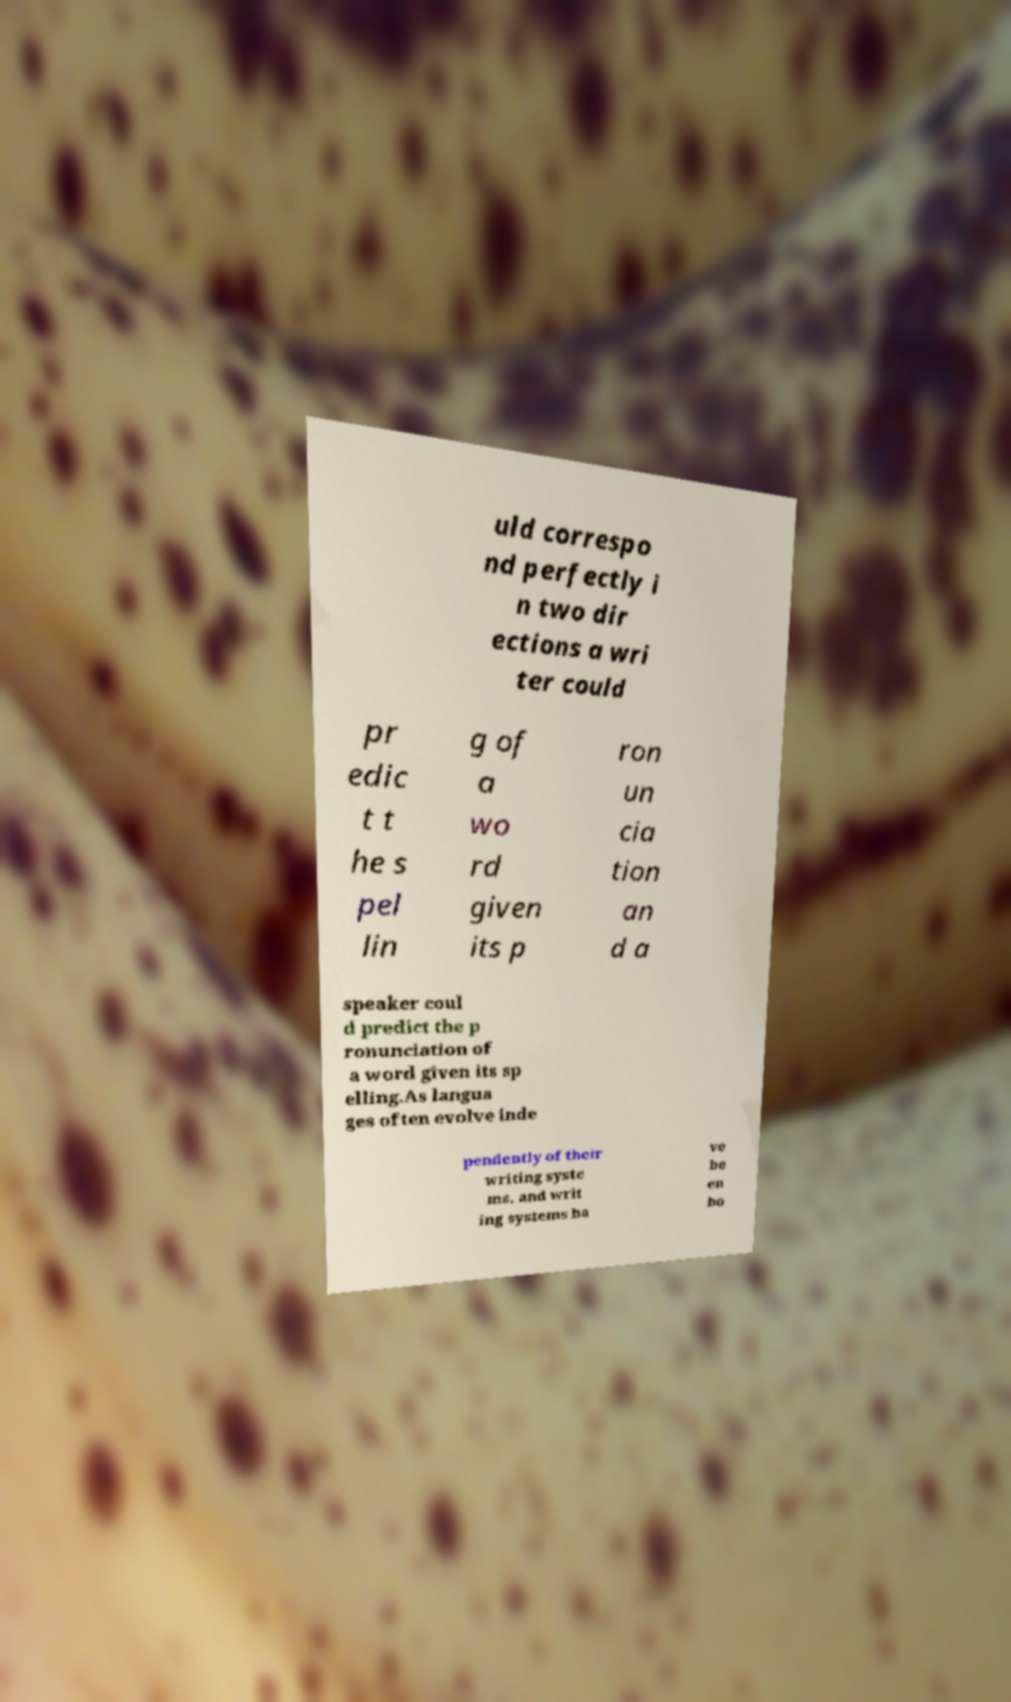There's text embedded in this image that I need extracted. Can you transcribe it verbatim? uld correspo nd perfectly i n two dir ections a wri ter could pr edic t t he s pel lin g of a wo rd given its p ron un cia tion an d a speaker coul d predict the p ronunciation of a word given its sp elling.As langua ges often evolve inde pendently of their writing syste ms, and writ ing systems ha ve be en bo 